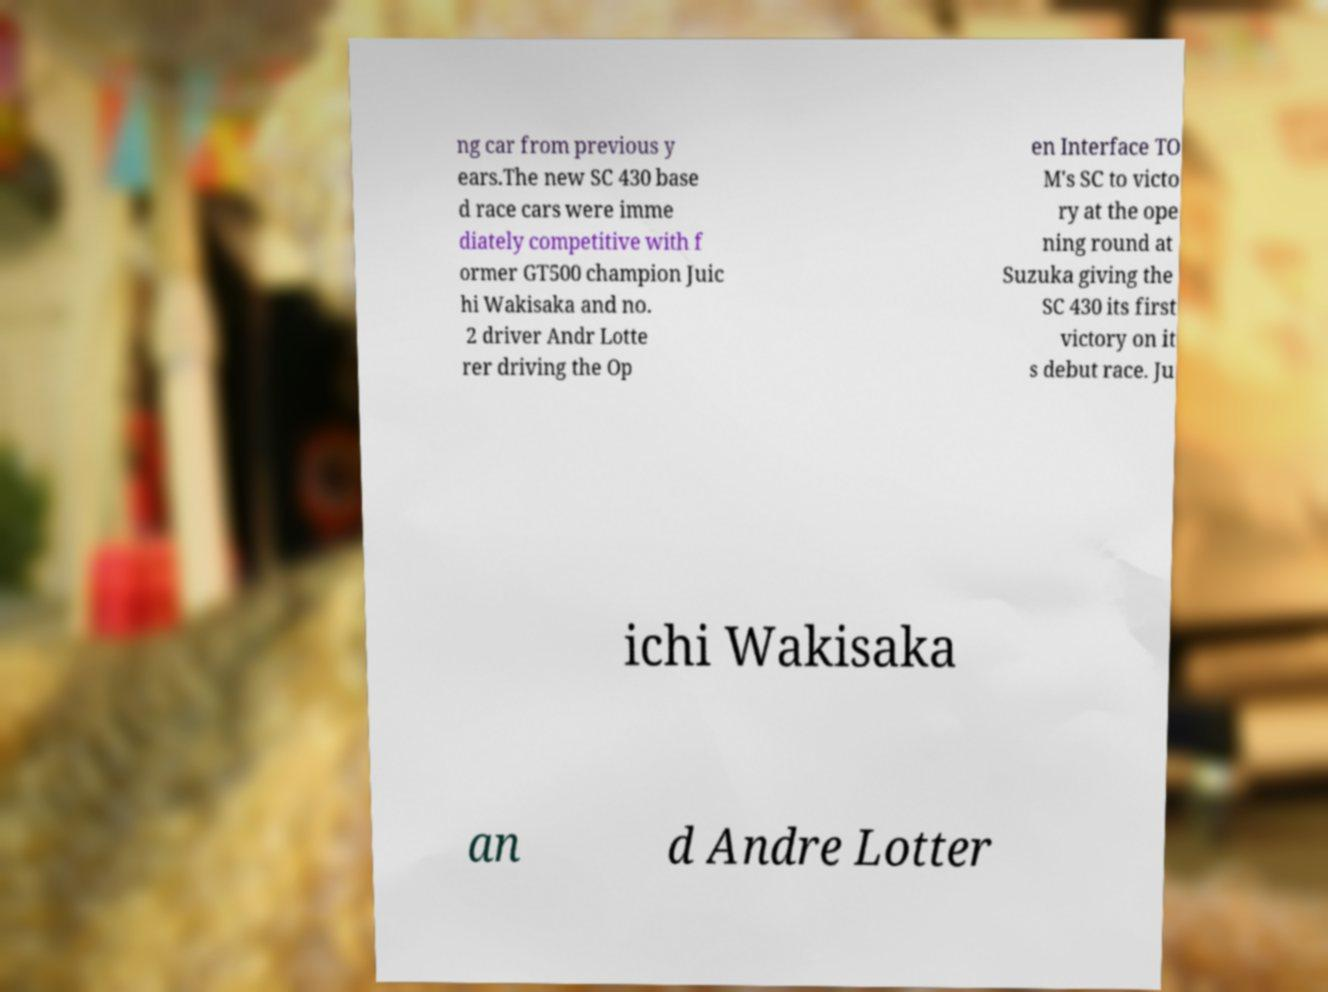Please read and relay the text visible in this image. What does it say? ng car from previous y ears.The new SC 430 base d race cars were imme diately competitive with f ormer GT500 champion Juic hi Wakisaka and no. 2 driver Andr Lotte rer driving the Op en Interface TO M's SC to victo ry at the ope ning round at Suzuka giving the SC 430 its first victory on it s debut race. Ju ichi Wakisaka an d Andre Lotter 